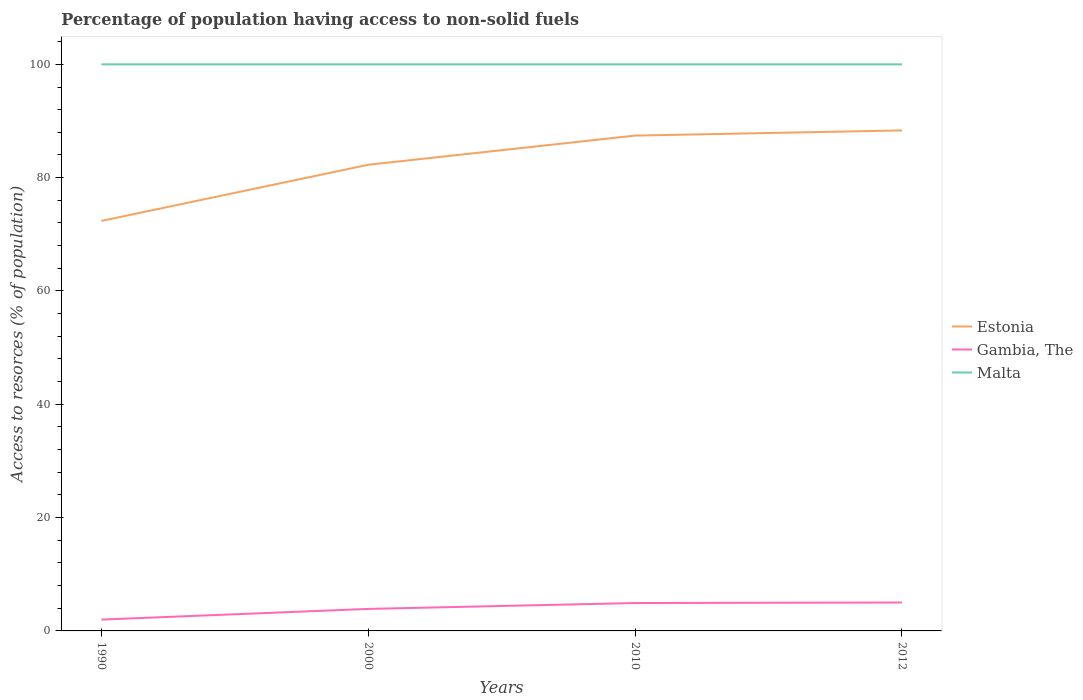Does the line corresponding to Gambia, The intersect with the line corresponding to Estonia?
Make the answer very short. No. Across all years, what is the maximum percentage of population having access to non-solid fuels in Estonia?
Keep it short and to the point. 72.36. What is the total percentage of population having access to non-solid fuels in Estonia in the graph?
Offer a terse response. -15.97. What is the difference between the highest and the second highest percentage of population having access to non-solid fuels in Estonia?
Keep it short and to the point. 15.97. What is the difference between the highest and the lowest percentage of population having access to non-solid fuels in Malta?
Give a very brief answer. 0. Is the percentage of population having access to non-solid fuels in Malta strictly greater than the percentage of population having access to non-solid fuels in Estonia over the years?
Your answer should be compact. No. What is the difference between two consecutive major ticks on the Y-axis?
Provide a short and direct response. 20. Does the graph contain any zero values?
Your answer should be compact. No. Does the graph contain grids?
Provide a short and direct response. No. How many legend labels are there?
Offer a terse response. 3. How are the legend labels stacked?
Offer a terse response. Vertical. What is the title of the graph?
Your answer should be compact. Percentage of population having access to non-solid fuels. What is the label or title of the X-axis?
Give a very brief answer. Years. What is the label or title of the Y-axis?
Offer a very short reply. Access to resorces (% of population). What is the Access to resorces (% of population) in Estonia in 1990?
Keep it short and to the point. 72.36. What is the Access to resorces (% of population) in Gambia, The in 1990?
Your answer should be very brief. 2. What is the Access to resorces (% of population) in Estonia in 2000?
Offer a very short reply. 82.28. What is the Access to resorces (% of population) of Gambia, The in 2000?
Your answer should be compact. 3.88. What is the Access to resorces (% of population) of Estonia in 2010?
Your response must be concise. 87.42. What is the Access to resorces (% of population) of Gambia, The in 2010?
Give a very brief answer. 4.92. What is the Access to resorces (% of population) in Malta in 2010?
Make the answer very short. 100. What is the Access to resorces (% of population) of Estonia in 2012?
Give a very brief answer. 88.34. What is the Access to resorces (% of population) in Gambia, The in 2012?
Offer a terse response. 5.02. What is the Access to resorces (% of population) of Malta in 2012?
Ensure brevity in your answer.  100. Across all years, what is the maximum Access to resorces (% of population) of Estonia?
Offer a very short reply. 88.34. Across all years, what is the maximum Access to resorces (% of population) of Gambia, The?
Your answer should be compact. 5.02. Across all years, what is the maximum Access to resorces (% of population) in Malta?
Give a very brief answer. 100. Across all years, what is the minimum Access to resorces (% of population) of Estonia?
Your response must be concise. 72.36. Across all years, what is the minimum Access to resorces (% of population) of Gambia, The?
Keep it short and to the point. 2. Across all years, what is the minimum Access to resorces (% of population) of Malta?
Provide a succinct answer. 100. What is the total Access to resorces (% of population) in Estonia in the graph?
Your answer should be very brief. 330.4. What is the total Access to resorces (% of population) in Gambia, The in the graph?
Your answer should be compact. 15.82. What is the total Access to resorces (% of population) in Malta in the graph?
Your answer should be very brief. 400. What is the difference between the Access to resorces (% of population) in Estonia in 1990 and that in 2000?
Provide a succinct answer. -9.91. What is the difference between the Access to resorces (% of population) of Gambia, The in 1990 and that in 2000?
Give a very brief answer. -1.88. What is the difference between the Access to resorces (% of population) of Estonia in 1990 and that in 2010?
Your answer should be very brief. -15.06. What is the difference between the Access to resorces (% of population) of Gambia, The in 1990 and that in 2010?
Your answer should be very brief. -2.92. What is the difference between the Access to resorces (% of population) in Estonia in 1990 and that in 2012?
Your answer should be very brief. -15.97. What is the difference between the Access to resorces (% of population) of Gambia, The in 1990 and that in 2012?
Your response must be concise. -3.02. What is the difference between the Access to resorces (% of population) of Estonia in 2000 and that in 2010?
Offer a terse response. -5.15. What is the difference between the Access to resorces (% of population) in Gambia, The in 2000 and that in 2010?
Keep it short and to the point. -1.04. What is the difference between the Access to resorces (% of population) of Estonia in 2000 and that in 2012?
Keep it short and to the point. -6.06. What is the difference between the Access to resorces (% of population) of Gambia, The in 2000 and that in 2012?
Ensure brevity in your answer.  -1.13. What is the difference between the Access to resorces (% of population) of Malta in 2000 and that in 2012?
Give a very brief answer. 0. What is the difference between the Access to resorces (% of population) in Estonia in 2010 and that in 2012?
Offer a terse response. -0.91. What is the difference between the Access to resorces (% of population) of Gambia, The in 2010 and that in 2012?
Keep it short and to the point. -0.09. What is the difference between the Access to resorces (% of population) of Malta in 2010 and that in 2012?
Your response must be concise. 0. What is the difference between the Access to resorces (% of population) in Estonia in 1990 and the Access to resorces (% of population) in Gambia, The in 2000?
Give a very brief answer. 68.48. What is the difference between the Access to resorces (% of population) in Estonia in 1990 and the Access to resorces (% of population) in Malta in 2000?
Provide a short and direct response. -27.64. What is the difference between the Access to resorces (% of population) of Gambia, The in 1990 and the Access to resorces (% of population) of Malta in 2000?
Provide a succinct answer. -98. What is the difference between the Access to resorces (% of population) of Estonia in 1990 and the Access to resorces (% of population) of Gambia, The in 2010?
Provide a short and direct response. 67.44. What is the difference between the Access to resorces (% of population) in Estonia in 1990 and the Access to resorces (% of population) in Malta in 2010?
Make the answer very short. -27.64. What is the difference between the Access to resorces (% of population) of Gambia, The in 1990 and the Access to resorces (% of population) of Malta in 2010?
Provide a succinct answer. -98. What is the difference between the Access to resorces (% of population) in Estonia in 1990 and the Access to resorces (% of population) in Gambia, The in 2012?
Provide a short and direct response. 67.35. What is the difference between the Access to resorces (% of population) of Estonia in 1990 and the Access to resorces (% of population) of Malta in 2012?
Ensure brevity in your answer.  -27.64. What is the difference between the Access to resorces (% of population) in Gambia, The in 1990 and the Access to resorces (% of population) in Malta in 2012?
Provide a succinct answer. -98. What is the difference between the Access to resorces (% of population) of Estonia in 2000 and the Access to resorces (% of population) of Gambia, The in 2010?
Your answer should be very brief. 77.35. What is the difference between the Access to resorces (% of population) in Estonia in 2000 and the Access to resorces (% of population) in Malta in 2010?
Ensure brevity in your answer.  -17.72. What is the difference between the Access to resorces (% of population) of Gambia, The in 2000 and the Access to resorces (% of population) of Malta in 2010?
Make the answer very short. -96.12. What is the difference between the Access to resorces (% of population) of Estonia in 2000 and the Access to resorces (% of population) of Gambia, The in 2012?
Your answer should be compact. 77.26. What is the difference between the Access to resorces (% of population) of Estonia in 2000 and the Access to resorces (% of population) of Malta in 2012?
Offer a terse response. -17.72. What is the difference between the Access to resorces (% of population) of Gambia, The in 2000 and the Access to resorces (% of population) of Malta in 2012?
Offer a very short reply. -96.12. What is the difference between the Access to resorces (% of population) of Estonia in 2010 and the Access to resorces (% of population) of Gambia, The in 2012?
Give a very brief answer. 82.41. What is the difference between the Access to resorces (% of population) of Estonia in 2010 and the Access to resorces (% of population) of Malta in 2012?
Your answer should be compact. -12.58. What is the difference between the Access to resorces (% of population) in Gambia, The in 2010 and the Access to resorces (% of population) in Malta in 2012?
Ensure brevity in your answer.  -95.08. What is the average Access to resorces (% of population) of Estonia per year?
Your answer should be very brief. 82.6. What is the average Access to resorces (% of population) in Gambia, The per year?
Offer a terse response. 3.96. In the year 1990, what is the difference between the Access to resorces (% of population) of Estonia and Access to resorces (% of population) of Gambia, The?
Keep it short and to the point. 70.36. In the year 1990, what is the difference between the Access to resorces (% of population) in Estonia and Access to resorces (% of population) in Malta?
Your answer should be compact. -27.64. In the year 1990, what is the difference between the Access to resorces (% of population) in Gambia, The and Access to resorces (% of population) in Malta?
Your answer should be very brief. -98. In the year 2000, what is the difference between the Access to resorces (% of population) in Estonia and Access to resorces (% of population) in Gambia, The?
Your answer should be compact. 78.39. In the year 2000, what is the difference between the Access to resorces (% of population) of Estonia and Access to resorces (% of population) of Malta?
Keep it short and to the point. -17.72. In the year 2000, what is the difference between the Access to resorces (% of population) in Gambia, The and Access to resorces (% of population) in Malta?
Ensure brevity in your answer.  -96.12. In the year 2010, what is the difference between the Access to resorces (% of population) of Estonia and Access to resorces (% of population) of Gambia, The?
Your answer should be very brief. 82.5. In the year 2010, what is the difference between the Access to resorces (% of population) in Estonia and Access to resorces (% of population) in Malta?
Offer a terse response. -12.58. In the year 2010, what is the difference between the Access to resorces (% of population) in Gambia, The and Access to resorces (% of population) in Malta?
Offer a terse response. -95.08. In the year 2012, what is the difference between the Access to resorces (% of population) of Estonia and Access to resorces (% of population) of Gambia, The?
Your response must be concise. 83.32. In the year 2012, what is the difference between the Access to resorces (% of population) in Estonia and Access to resorces (% of population) in Malta?
Your answer should be very brief. -11.66. In the year 2012, what is the difference between the Access to resorces (% of population) in Gambia, The and Access to resorces (% of population) in Malta?
Your answer should be very brief. -94.98. What is the ratio of the Access to resorces (% of population) of Estonia in 1990 to that in 2000?
Offer a very short reply. 0.88. What is the ratio of the Access to resorces (% of population) of Gambia, The in 1990 to that in 2000?
Give a very brief answer. 0.51. What is the ratio of the Access to resorces (% of population) in Estonia in 1990 to that in 2010?
Make the answer very short. 0.83. What is the ratio of the Access to resorces (% of population) in Gambia, The in 1990 to that in 2010?
Make the answer very short. 0.41. What is the ratio of the Access to resorces (% of population) of Estonia in 1990 to that in 2012?
Make the answer very short. 0.82. What is the ratio of the Access to resorces (% of population) of Gambia, The in 1990 to that in 2012?
Make the answer very short. 0.4. What is the ratio of the Access to resorces (% of population) in Malta in 1990 to that in 2012?
Keep it short and to the point. 1. What is the ratio of the Access to resorces (% of population) of Estonia in 2000 to that in 2010?
Offer a very short reply. 0.94. What is the ratio of the Access to resorces (% of population) of Gambia, The in 2000 to that in 2010?
Ensure brevity in your answer.  0.79. What is the ratio of the Access to resorces (% of population) of Malta in 2000 to that in 2010?
Ensure brevity in your answer.  1. What is the ratio of the Access to resorces (% of population) of Estonia in 2000 to that in 2012?
Give a very brief answer. 0.93. What is the ratio of the Access to resorces (% of population) of Gambia, The in 2000 to that in 2012?
Provide a short and direct response. 0.77. What is the ratio of the Access to resorces (% of population) in Malta in 2000 to that in 2012?
Provide a short and direct response. 1. What is the ratio of the Access to resorces (% of population) in Estonia in 2010 to that in 2012?
Offer a terse response. 0.99. What is the ratio of the Access to resorces (% of population) in Gambia, The in 2010 to that in 2012?
Your answer should be compact. 0.98. What is the difference between the highest and the second highest Access to resorces (% of population) in Estonia?
Offer a terse response. 0.91. What is the difference between the highest and the second highest Access to resorces (% of population) in Gambia, The?
Provide a succinct answer. 0.09. What is the difference between the highest and the lowest Access to resorces (% of population) of Estonia?
Your answer should be compact. 15.97. What is the difference between the highest and the lowest Access to resorces (% of population) in Gambia, The?
Give a very brief answer. 3.02. What is the difference between the highest and the lowest Access to resorces (% of population) of Malta?
Provide a succinct answer. 0. 